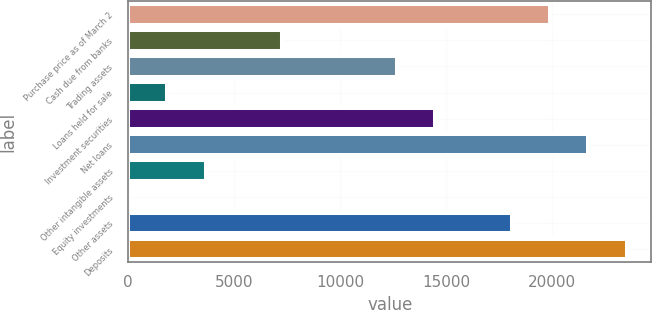Convert chart to OTSL. <chart><loc_0><loc_0><loc_500><loc_500><bar_chart><fcel>Purchase price as of March 2<fcel>Cash due from banks<fcel>Trading assets<fcel>Loans held for sale<fcel>Investment securities<fcel>Net loans<fcel>Other intangible assets<fcel>Equity investments<fcel>Other assets<fcel>Deposits<nl><fcel>19899.9<fcel>7258.6<fcel>12676.3<fcel>1840.9<fcel>14482.2<fcel>21705.8<fcel>3646.8<fcel>35<fcel>18094<fcel>23511.7<nl></chart> 